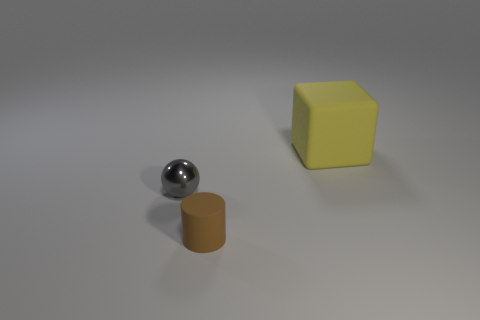The thing that is behind the tiny brown matte cylinder and to the right of the metal object is what color?
Your answer should be compact. Yellow. There is a matte thing that is to the left of the thing that is behind the small gray shiny ball; are there any gray metallic spheres that are left of it?
Keep it short and to the point. Yes. Are there any other things that are made of the same material as the small sphere?
Give a very brief answer. No. Are there any big yellow blocks?
Provide a succinct answer. Yes. What size is the rubber thing that is behind the small object behind the matte thing that is in front of the yellow cube?
Ensure brevity in your answer.  Large. What number of big cubes have the same color as the metallic object?
Your response must be concise. 0. How many objects are either small brown metal blocks or things behind the brown matte object?
Your answer should be compact. 2. The cube has what color?
Offer a terse response. Yellow. The matte object that is behind the small brown matte cylinder is what color?
Your answer should be very brief. Yellow. There is a small object behind the small brown rubber cylinder; what number of big yellow blocks are in front of it?
Your response must be concise. 0. 